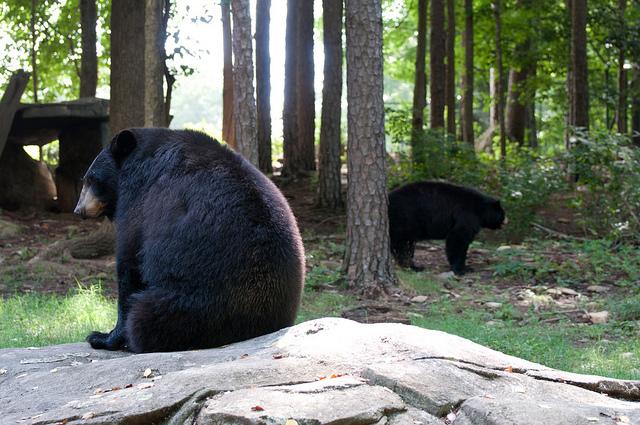What time of day is it?
Answer briefly. Morning. How many animals are in this picture?
Keep it brief. 2. What is the large tree behind the bear planted in?
Write a very short answer. Ground. 